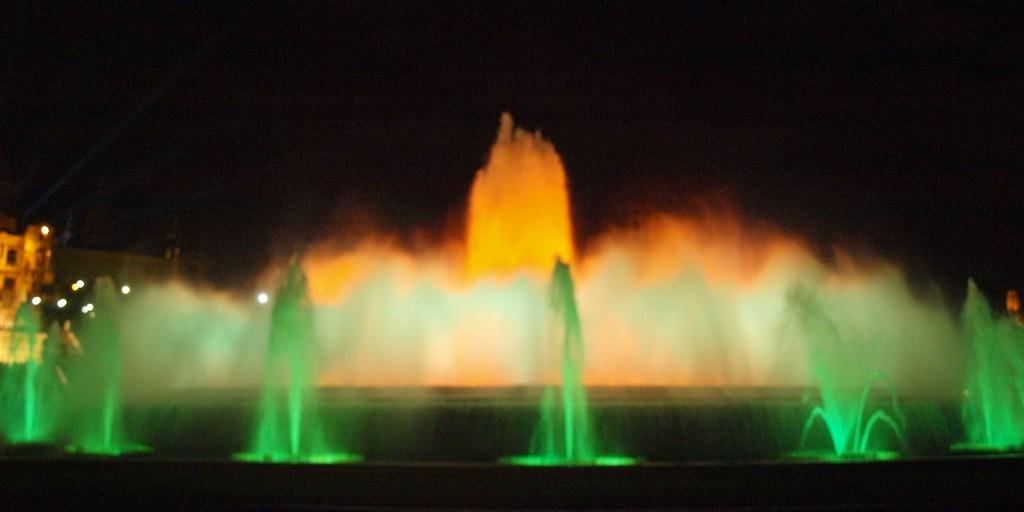What is the main subject of the picture? The main subject of the picture is a fountain. Can you describe the fountain in the picture? The fountain has different colors. What can be seen in the background of the picture? There is a building visible in the background of the picture. Where is the throne located in the picture? There is no throne present in the picture; it features a fountain and a building in the background. What idea does the fountain represent in the picture? The picture does not convey any specific ideas or concepts; it simply depicts a colorful fountain and a building in the background. 